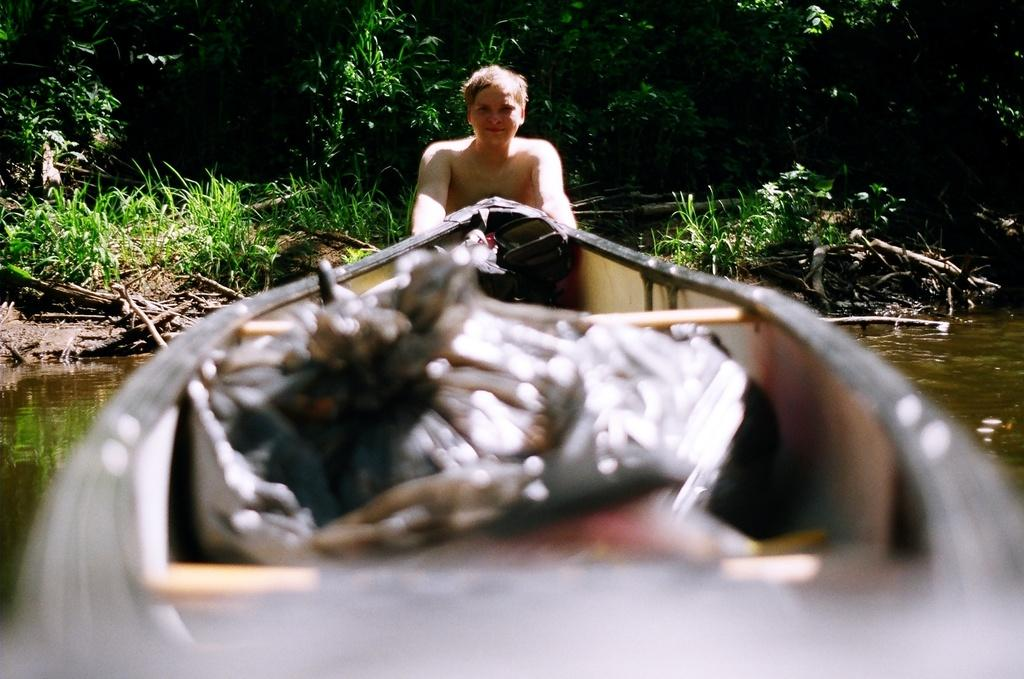What is the main subject in the foreground of the image? There is a boat in the foreground of the image. What else can be seen in the foreground of the image? There is a person in the water in the foreground of the image. What type of vegetation is visible in the background of the image? There are plants and trees in the background of the image. What might be the location of the image? The image may have been taken near a lake, given the presence of water and boats. What type of crow can be seen coiled around the tree in the image? There is no crow present in the image, nor is there any coiling around the trees. 